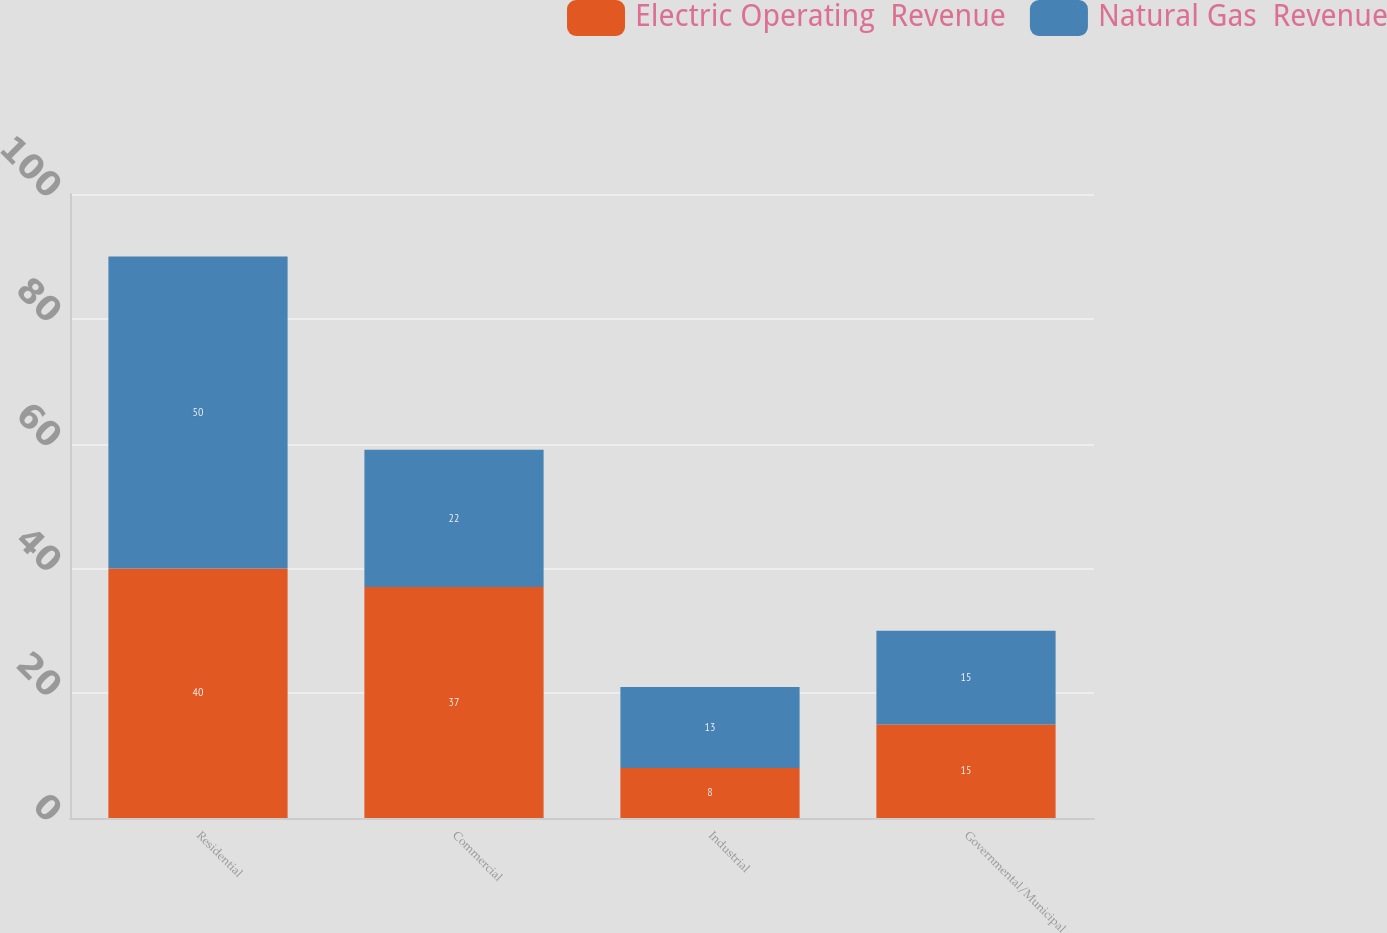<chart> <loc_0><loc_0><loc_500><loc_500><stacked_bar_chart><ecel><fcel>Residential<fcel>Commercial<fcel>Industrial<fcel>Governmental/Municipal<nl><fcel>Electric Operating  Revenue<fcel>40<fcel>37<fcel>8<fcel>15<nl><fcel>Natural Gas  Revenue<fcel>50<fcel>22<fcel>13<fcel>15<nl></chart> 